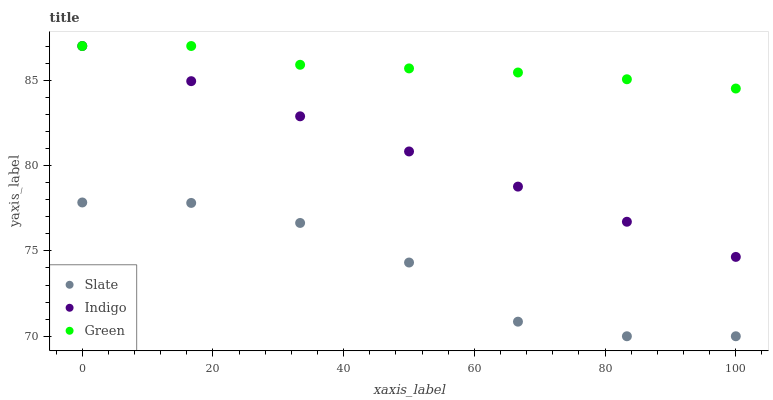Does Slate have the minimum area under the curve?
Answer yes or no. Yes. Does Green have the maximum area under the curve?
Answer yes or no. Yes. Does Indigo have the minimum area under the curve?
Answer yes or no. No. Does Indigo have the maximum area under the curve?
Answer yes or no. No. Is Indigo the smoothest?
Answer yes or no. Yes. Is Slate the roughest?
Answer yes or no. Yes. Is Slate the smoothest?
Answer yes or no. No. Is Indigo the roughest?
Answer yes or no. No. Does Slate have the lowest value?
Answer yes or no. Yes. Does Indigo have the lowest value?
Answer yes or no. No. Does Indigo have the highest value?
Answer yes or no. Yes. Does Slate have the highest value?
Answer yes or no. No. Is Slate less than Indigo?
Answer yes or no. Yes. Is Indigo greater than Slate?
Answer yes or no. Yes. Does Green intersect Indigo?
Answer yes or no. Yes. Is Green less than Indigo?
Answer yes or no. No. Is Green greater than Indigo?
Answer yes or no. No. Does Slate intersect Indigo?
Answer yes or no. No. 